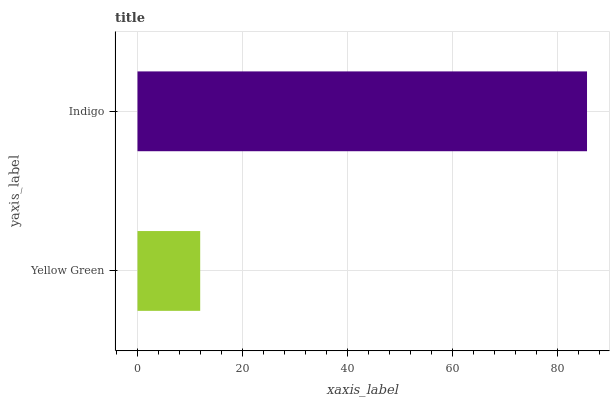Is Yellow Green the minimum?
Answer yes or no. Yes. Is Indigo the maximum?
Answer yes or no. Yes. Is Indigo the minimum?
Answer yes or no. No. Is Indigo greater than Yellow Green?
Answer yes or no. Yes. Is Yellow Green less than Indigo?
Answer yes or no. Yes. Is Yellow Green greater than Indigo?
Answer yes or no. No. Is Indigo less than Yellow Green?
Answer yes or no. No. Is Indigo the high median?
Answer yes or no. Yes. Is Yellow Green the low median?
Answer yes or no. Yes. Is Yellow Green the high median?
Answer yes or no. No. Is Indigo the low median?
Answer yes or no. No. 